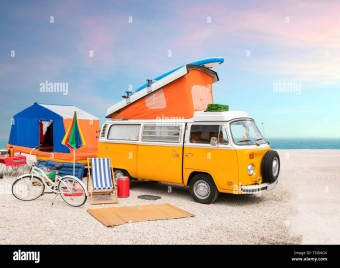How many chairs would there be in the image now that no more chair has been moved to the scence? 1 